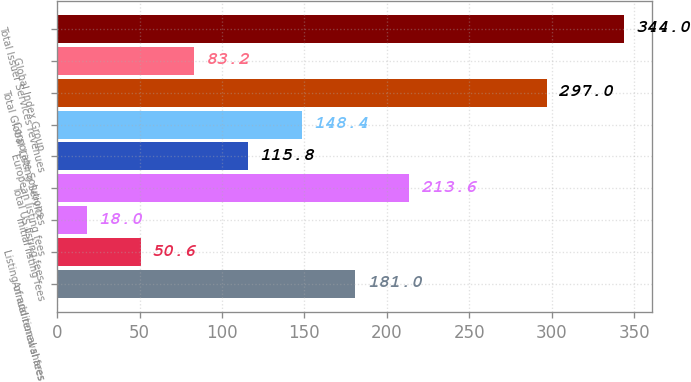Convert chart to OTSL. <chart><loc_0><loc_0><loc_500><loc_500><bar_chart><fcel>Annual renewal fees<fcel>Listing of additional shares<fcel>Initial listing fees<fcel>Total US listing fees<fcel>European listing fees<fcel>Corporate Solutions<fcel>Total Global Listing Services<fcel>Global Index Group<fcel>Total Issuer Services revenues<nl><fcel>181<fcel>50.6<fcel>18<fcel>213.6<fcel>115.8<fcel>148.4<fcel>297<fcel>83.2<fcel>344<nl></chart> 